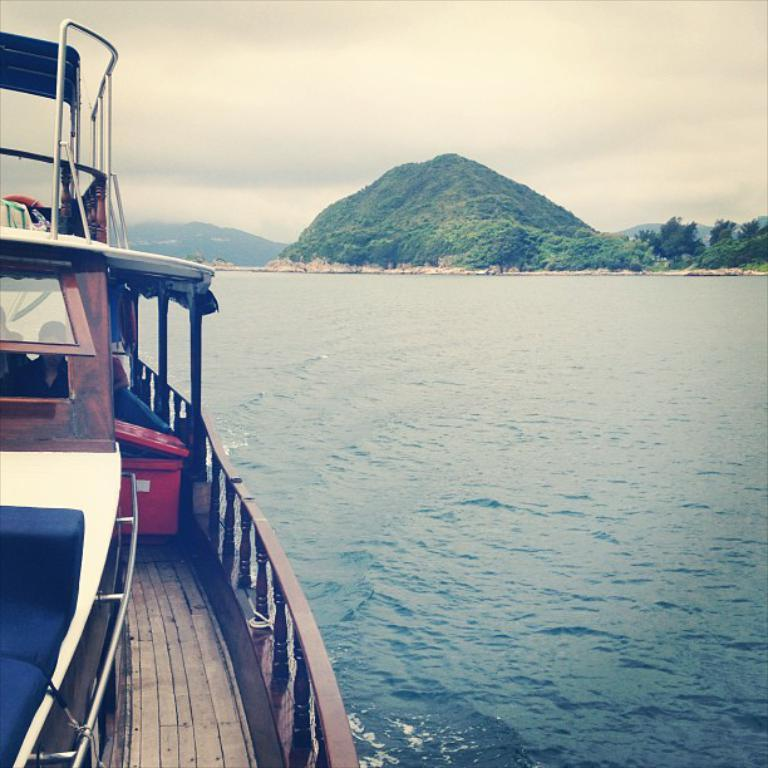What is located on the left side of the image? There is a boat on the left side of the image. Where is the boat situated? The boat is on the water. What can be seen in the background of the image? There is water, hills, and the sky visible in the background of the image. How many eggs are being used to propel the boat in the image? There are no eggs present in the image, and they are not used to propel the boat. 